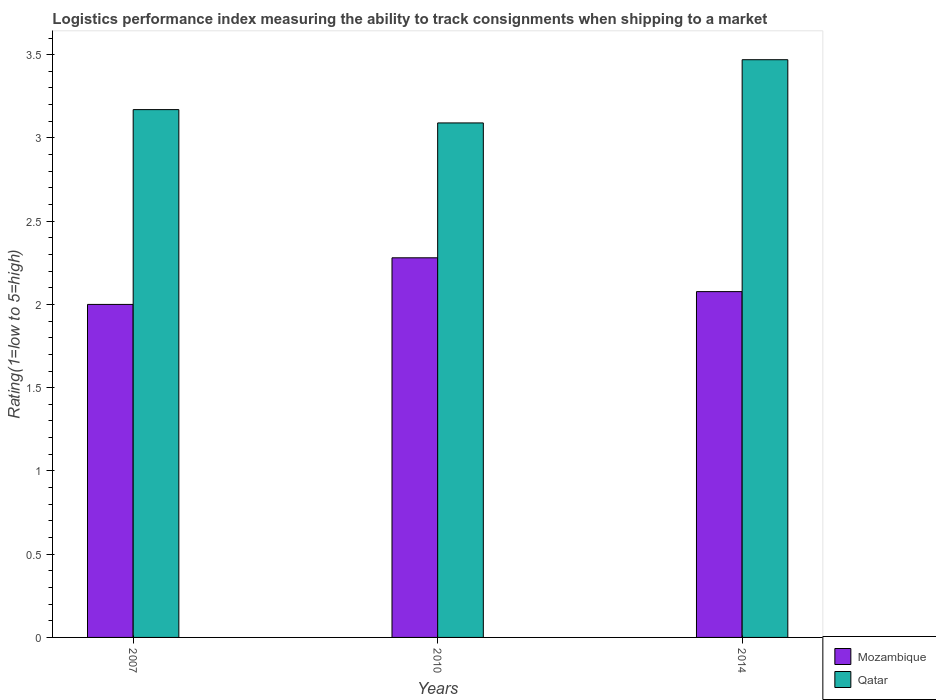How many groups of bars are there?
Offer a very short reply. 3. Are the number of bars per tick equal to the number of legend labels?
Provide a succinct answer. Yes. How many bars are there on the 3rd tick from the left?
Provide a short and direct response. 2. What is the label of the 1st group of bars from the left?
Give a very brief answer. 2007. What is the Logistic performance index in Qatar in 2014?
Ensure brevity in your answer.  3.47. Across all years, what is the maximum Logistic performance index in Qatar?
Keep it short and to the point. 3.47. Across all years, what is the minimum Logistic performance index in Mozambique?
Provide a short and direct response. 2. What is the total Logistic performance index in Mozambique in the graph?
Give a very brief answer. 6.36. What is the difference between the Logistic performance index in Mozambique in 2007 and that in 2014?
Give a very brief answer. -0.08. What is the difference between the Logistic performance index in Qatar in 2007 and the Logistic performance index in Mozambique in 2014?
Ensure brevity in your answer.  1.09. What is the average Logistic performance index in Qatar per year?
Your response must be concise. 3.24. In the year 2007, what is the difference between the Logistic performance index in Mozambique and Logistic performance index in Qatar?
Provide a short and direct response. -1.17. What is the ratio of the Logistic performance index in Mozambique in 2010 to that in 2014?
Keep it short and to the point. 1.1. What is the difference between the highest and the second highest Logistic performance index in Mozambique?
Keep it short and to the point. 0.2. What is the difference between the highest and the lowest Logistic performance index in Qatar?
Your answer should be compact. 0.38. In how many years, is the Logistic performance index in Mozambique greater than the average Logistic performance index in Mozambique taken over all years?
Ensure brevity in your answer.  1. Is the sum of the Logistic performance index in Qatar in 2007 and 2010 greater than the maximum Logistic performance index in Mozambique across all years?
Offer a terse response. Yes. What does the 1st bar from the left in 2014 represents?
Your response must be concise. Mozambique. What does the 2nd bar from the right in 2007 represents?
Keep it short and to the point. Mozambique. How many years are there in the graph?
Your response must be concise. 3. Does the graph contain any zero values?
Give a very brief answer. No. Does the graph contain grids?
Provide a short and direct response. No. Where does the legend appear in the graph?
Provide a short and direct response. Bottom right. How are the legend labels stacked?
Offer a very short reply. Vertical. What is the title of the graph?
Provide a succinct answer. Logistics performance index measuring the ability to track consignments when shipping to a market. Does "Burkina Faso" appear as one of the legend labels in the graph?
Your response must be concise. No. What is the label or title of the Y-axis?
Offer a terse response. Rating(1=low to 5=high). What is the Rating(1=low to 5=high) of Mozambique in 2007?
Make the answer very short. 2. What is the Rating(1=low to 5=high) in Qatar in 2007?
Ensure brevity in your answer.  3.17. What is the Rating(1=low to 5=high) in Mozambique in 2010?
Your response must be concise. 2.28. What is the Rating(1=low to 5=high) in Qatar in 2010?
Offer a terse response. 3.09. What is the Rating(1=low to 5=high) in Mozambique in 2014?
Provide a succinct answer. 2.08. What is the Rating(1=low to 5=high) in Qatar in 2014?
Offer a terse response. 3.47. Across all years, what is the maximum Rating(1=low to 5=high) in Mozambique?
Provide a short and direct response. 2.28. Across all years, what is the maximum Rating(1=low to 5=high) in Qatar?
Your response must be concise. 3.47. Across all years, what is the minimum Rating(1=low to 5=high) in Mozambique?
Provide a short and direct response. 2. Across all years, what is the minimum Rating(1=low to 5=high) of Qatar?
Provide a succinct answer. 3.09. What is the total Rating(1=low to 5=high) in Mozambique in the graph?
Your answer should be very brief. 6.36. What is the total Rating(1=low to 5=high) in Qatar in the graph?
Give a very brief answer. 9.73. What is the difference between the Rating(1=low to 5=high) of Mozambique in 2007 and that in 2010?
Make the answer very short. -0.28. What is the difference between the Rating(1=low to 5=high) of Qatar in 2007 and that in 2010?
Offer a very short reply. 0.08. What is the difference between the Rating(1=low to 5=high) in Mozambique in 2007 and that in 2014?
Provide a succinct answer. -0.08. What is the difference between the Rating(1=low to 5=high) of Qatar in 2007 and that in 2014?
Offer a terse response. -0.3. What is the difference between the Rating(1=low to 5=high) in Mozambique in 2010 and that in 2014?
Offer a terse response. 0.2. What is the difference between the Rating(1=low to 5=high) of Qatar in 2010 and that in 2014?
Ensure brevity in your answer.  -0.38. What is the difference between the Rating(1=low to 5=high) of Mozambique in 2007 and the Rating(1=low to 5=high) of Qatar in 2010?
Make the answer very short. -1.09. What is the difference between the Rating(1=low to 5=high) of Mozambique in 2007 and the Rating(1=low to 5=high) of Qatar in 2014?
Your answer should be compact. -1.47. What is the difference between the Rating(1=low to 5=high) of Mozambique in 2010 and the Rating(1=low to 5=high) of Qatar in 2014?
Give a very brief answer. -1.19. What is the average Rating(1=low to 5=high) of Mozambique per year?
Ensure brevity in your answer.  2.12. What is the average Rating(1=low to 5=high) of Qatar per year?
Keep it short and to the point. 3.24. In the year 2007, what is the difference between the Rating(1=low to 5=high) in Mozambique and Rating(1=low to 5=high) in Qatar?
Keep it short and to the point. -1.17. In the year 2010, what is the difference between the Rating(1=low to 5=high) of Mozambique and Rating(1=low to 5=high) of Qatar?
Give a very brief answer. -0.81. In the year 2014, what is the difference between the Rating(1=low to 5=high) in Mozambique and Rating(1=low to 5=high) in Qatar?
Provide a succinct answer. -1.39. What is the ratio of the Rating(1=low to 5=high) of Mozambique in 2007 to that in 2010?
Ensure brevity in your answer.  0.88. What is the ratio of the Rating(1=low to 5=high) in Qatar in 2007 to that in 2010?
Make the answer very short. 1.03. What is the ratio of the Rating(1=low to 5=high) of Mozambique in 2007 to that in 2014?
Provide a short and direct response. 0.96. What is the ratio of the Rating(1=low to 5=high) in Qatar in 2007 to that in 2014?
Your response must be concise. 0.91. What is the ratio of the Rating(1=low to 5=high) of Mozambique in 2010 to that in 2014?
Your answer should be very brief. 1.1. What is the ratio of the Rating(1=low to 5=high) in Qatar in 2010 to that in 2014?
Your answer should be compact. 0.89. What is the difference between the highest and the second highest Rating(1=low to 5=high) of Mozambique?
Give a very brief answer. 0.2. What is the difference between the highest and the second highest Rating(1=low to 5=high) in Qatar?
Ensure brevity in your answer.  0.3. What is the difference between the highest and the lowest Rating(1=low to 5=high) in Mozambique?
Your answer should be very brief. 0.28. What is the difference between the highest and the lowest Rating(1=low to 5=high) in Qatar?
Offer a terse response. 0.38. 